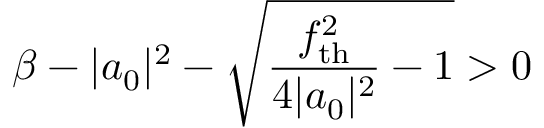Convert formula to latex. <formula><loc_0><loc_0><loc_500><loc_500>\beta - | a _ { 0 } | ^ { 2 } - \sqrt { \frac { f _ { t h } ^ { 2 } } { 4 | a _ { 0 } | ^ { 2 } } - 1 } > 0</formula> 